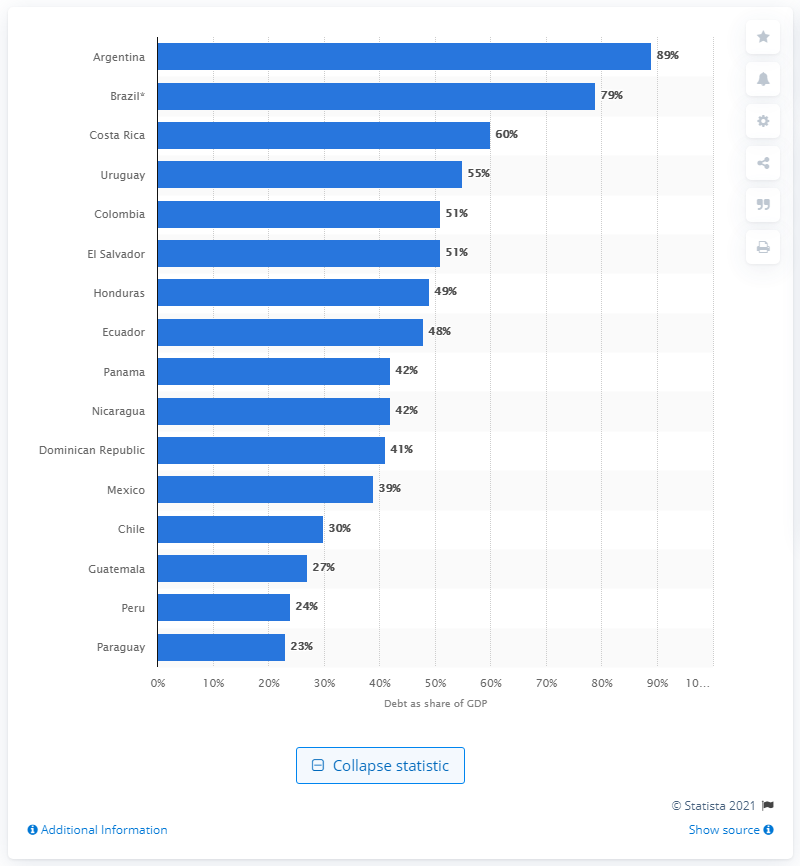Indicate a few pertinent items in this graphic. A significant portion of Argentina's Gross Domestic Product (GDP) is held by Brazil. According to data, approximately 89% of Argentina's Gross Domestic Product is held by the central government. 